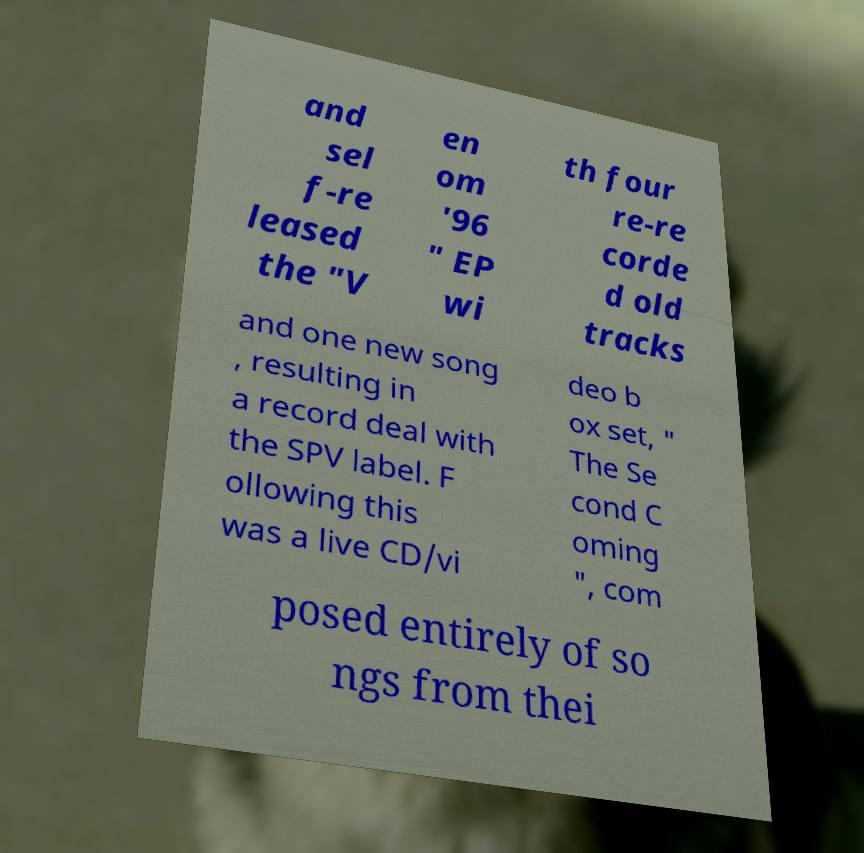Please read and relay the text visible in this image. What does it say? and sel f-re leased the "V en om '96 " EP wi th four re-re corde d old tracks and one new song , resulting in a record deal with the SPV label. F ollowing this was a live CD/vi deo b ox set, " The Se cond C oming ", com posed entirely of so ngs from thei 